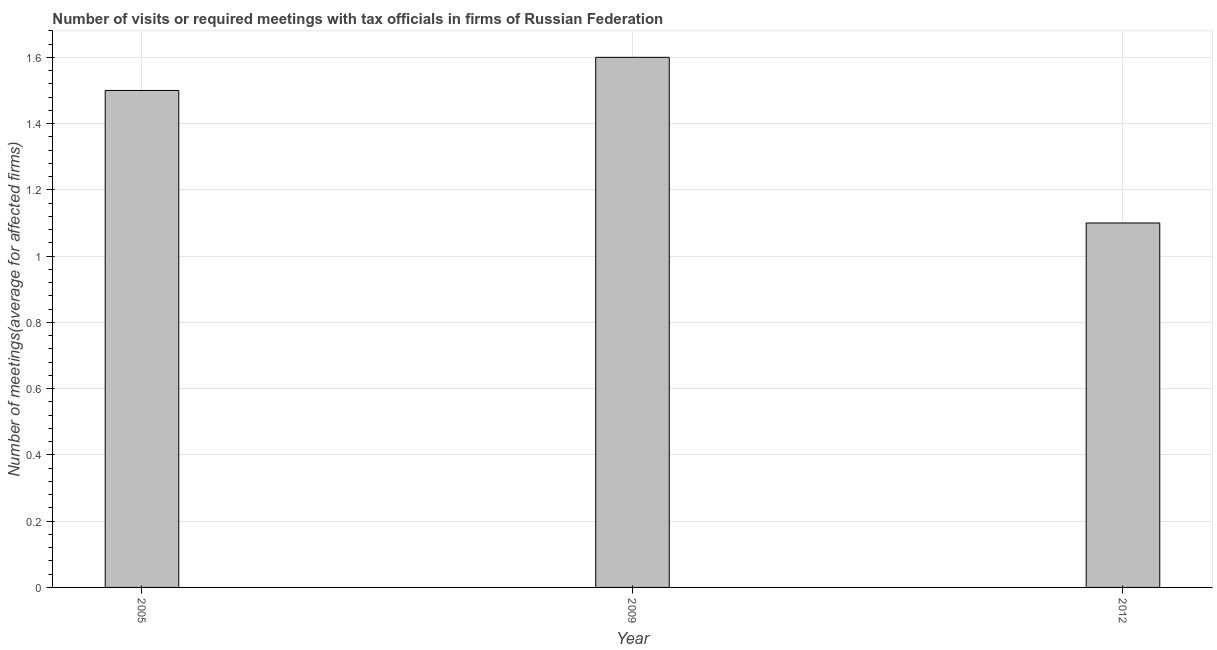Does the graph contain grids?
Your response must be concise. Yes. What is the title of the graph?
Give a very brief answer. Number of visits or required meetings with tax officials in firms of Russian Federation. What is the label or title of the Y-axis?
Provide a short and direct response. Number of meetings(average for affected firms). Across all years, what is the maximum number of required meetings with tax officials?
Offer a very short reply. 1.6. Across all years, what is the minimum number of required meetings with tax officials?
Ensure brevity in your answer.  1.1. In which year was the number of required meetings with tax officials maximum?
Your answer should be very brief. 2009. In which year was the number of required meetings with tax officials minimum?
Ensure brevity in your answer.  2012. What is the difference between the number of required meetings with tax officials in 2009 and 2012?
Your answer should be very brief. 0.5. What is the average number of required meetings with tax officials per year?
Offer a terse response. 1.4. In how many years, is the number of required meetings with tax officials greater than 0.16 ?
Your answer should be compact. 3. What is the ratio of the number of required meetings with tax officials in 2005 to that in 2012?
Your response must be concise. 1.36. Is the difference between the number of required meetings with tax officials in 2005 and 2009 greater than the difference between any two years?
Your response must be concise. No. Is the sum of the number of required meetings with tax officials in 2005 and 2012 greater than the maximum number of required meetings with tax officials across all years?
Keep it short and to the point. Yes. How many bars are there?
Your answer should be very brief. 3. Are the values on the major ticks of Y-axis written in scientific E-notation?
Your answer should be compact. No. What is the Number of meetings(average for affected firms) in 2005?
Offer a terse response. 1.5. What is the Number of meetings(average for affected firms) in 2009?
Your answer should be compact. 1.6. What is the difference between the Number of meetings(average for affected firms) in 2005 and 2009?
Make the answer very short. -0.1. What is the difference between the Number of meetings(average for affected firms) in 2005 and 2012?
Make the answer very short. 0.4. What is the difference between the Number of meetings(average for affected firms) in 2009 and 2012?
Give a very brief answer. 0.5. What is the ratio of the Number of meetings(average for affected firms) in 2005 to that in 2009?
Offer a terse response. 0.94. What is the ratio of the Number of meetings(average for affected firms) in 2005 to that in 2012?
Your answer should be compact. 1.36. What is the ratio of the Number of meetings(average for affected firms) in 2009 to that in 2012?
Give a very brief answer. 1.46. 